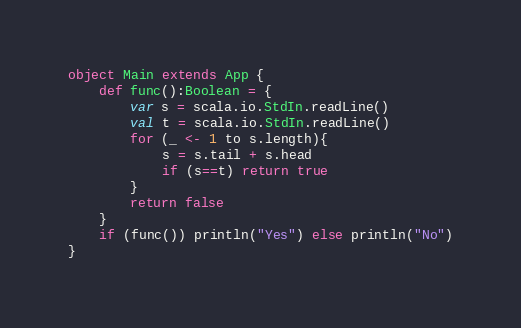<code> <loc_0><loc_0><loc_500><loc_500><_Scala_>object Main extends App {
    def func():Boolean = {
        var s = scala.io.StdIn.readLine()
        val t = scala.io.StdIn.readLine()
        for (_ <- 1 to s.length){
            s = s.tail + s.head
            if (s==t) return true
        }
        return false
    }
    if (func()) println("Yes") else println("No")
}</code> 